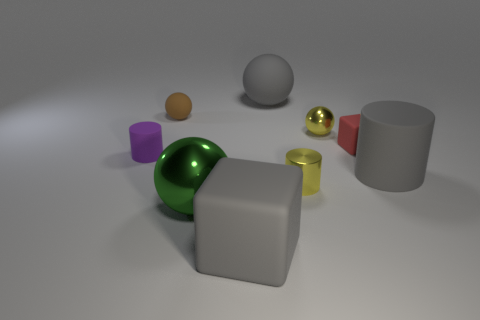Subtract all yellow balls. How many balls are left? 3 Subtract all brown balls. How many balls are left? 3 Subtract 1 cylinders. How many cylinders are left? 2 Subtract all cyan balls. Subtract all purple cylinders. How many balls are left? 4 Subtract all spheres. How many objects are left? 5 Subtract all large cyan cylinders. Subtract all large gray matte objects. How many objects are left? 6 Add 3 gray things. How many gray things are left? 6 Add 4 small green cubes. How many small green cubes exist? 4 Subtract 0 cyan balls. How many objects are left? 9 